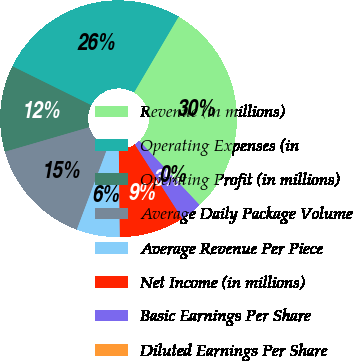<chart> <loc_0><loc_0><loc_500><loc_500><pie_chart><fcel>Revenue (in millions)<fcel>Operating Expenses (in<fcel>Operating Profit (in millions)<fcel>Average Daily Package Volume<fcel>Average Revenue Per Piece<fcel>Net Income (in millions)<fcel>Basic Earnings Per Share<fcel>Diluted Earnings Per Share<nl><fcel>29.53%<fcel>26.16%<fcel>11.81%<fcel>14.77%<fcel>5.91%<fcel>8.86%<fcel>2.96%<fcel>0.0%<nl></chart> 